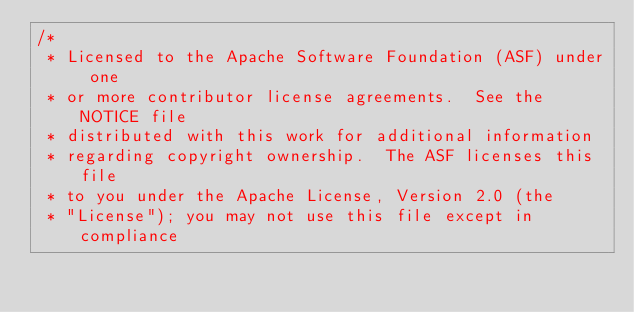Convert code to text. <code><loc_0><loc_0><loc_500><loc_500><_C_>/*
 * Licensed to the Apache Software Foundation (ASF) under one
 * or more contributor license agreements.  See the NOTICE file
 * distributed with this work for additional information
 * regarding copyright ownership.  The ASF licenses this file
 * to you under the Apache License, Version 2.0 (the
 * "License"); you may not use this file except in compliance</code> 